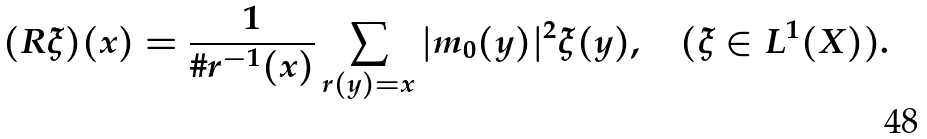Convert formula to latex. <formula><loc_0><loc_0><loc_500><loc_500>( R \xi ) ( x ) = \frac { 1 } { \# r ^ { - 1 } ( x ) } \sum _ { r ( y ) = x } | m _ { 0 } ( y ) | ^ { 2 } \xi ( y ) , \quad ( \xi \in L ^ { 1 } ( X ) ) .</formula> 